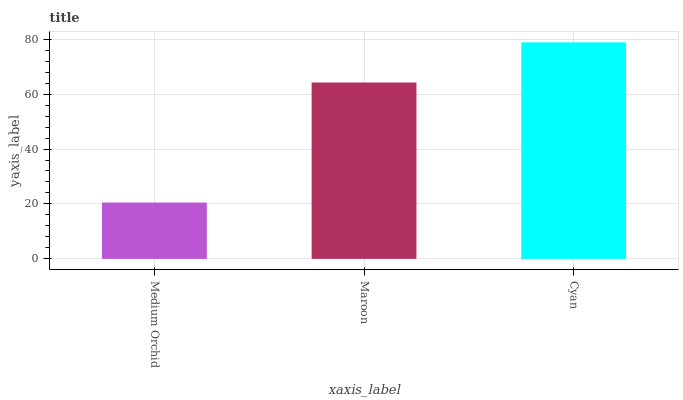Is Medium Orchid the minimum?
Answer yes or no. Yes. Is Cyan the maximum?
Answer yes or no. Yes. Is Maroon the minimum?
Answer yes or no. No. Is Maroon the maximum?
Answer yes or no. No. Is Maroon greater than Medium Orchid?
Answer yes or no. Yes. Is Medium Orchid less than Maroon?
Answer yes or no. Yes. Is Medium Orchid greater than Maroon?
Answer yes or no. No. Is Maroon less than Medium Orchid?
Answer yes or no. No. Is Maroon the high median?
Answer yes or no. Yes. Is Maroon the low median?
Answer yes or no. Yes. Is Medium Orchid the high median?
Answer yes or no. No. Is Medium Orchid the low median?
Answer yes or no. No. 